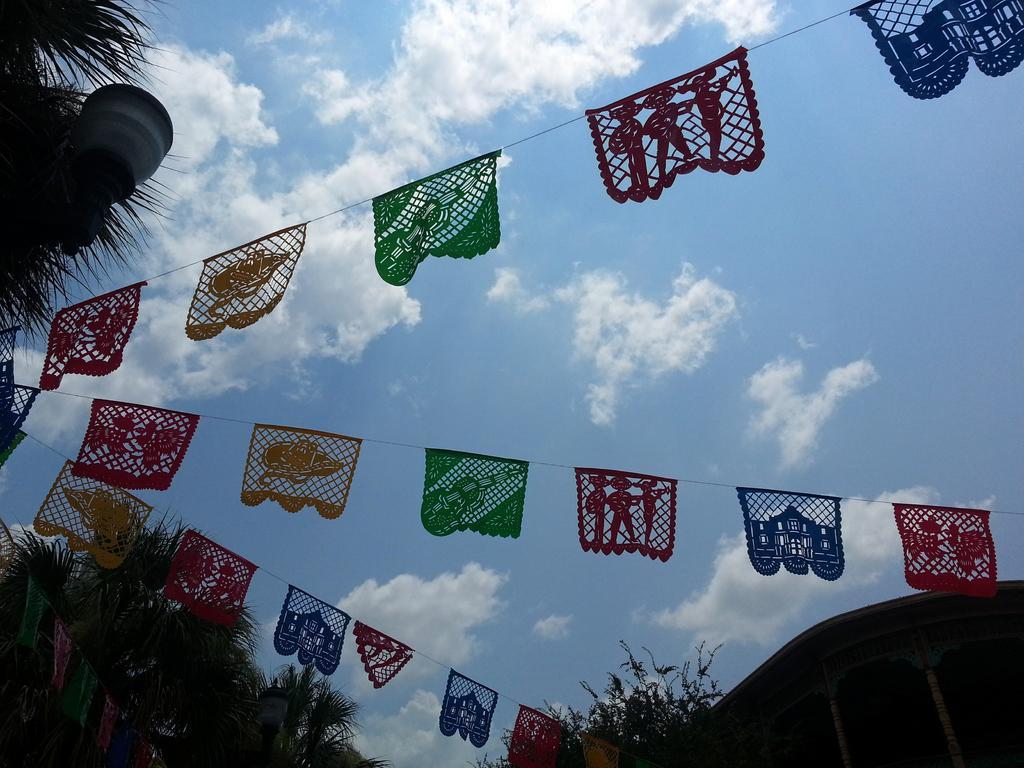Please provide a concise description of this image. In this picture we can see few trees, light, building and few flags, and also we can see clouds. 